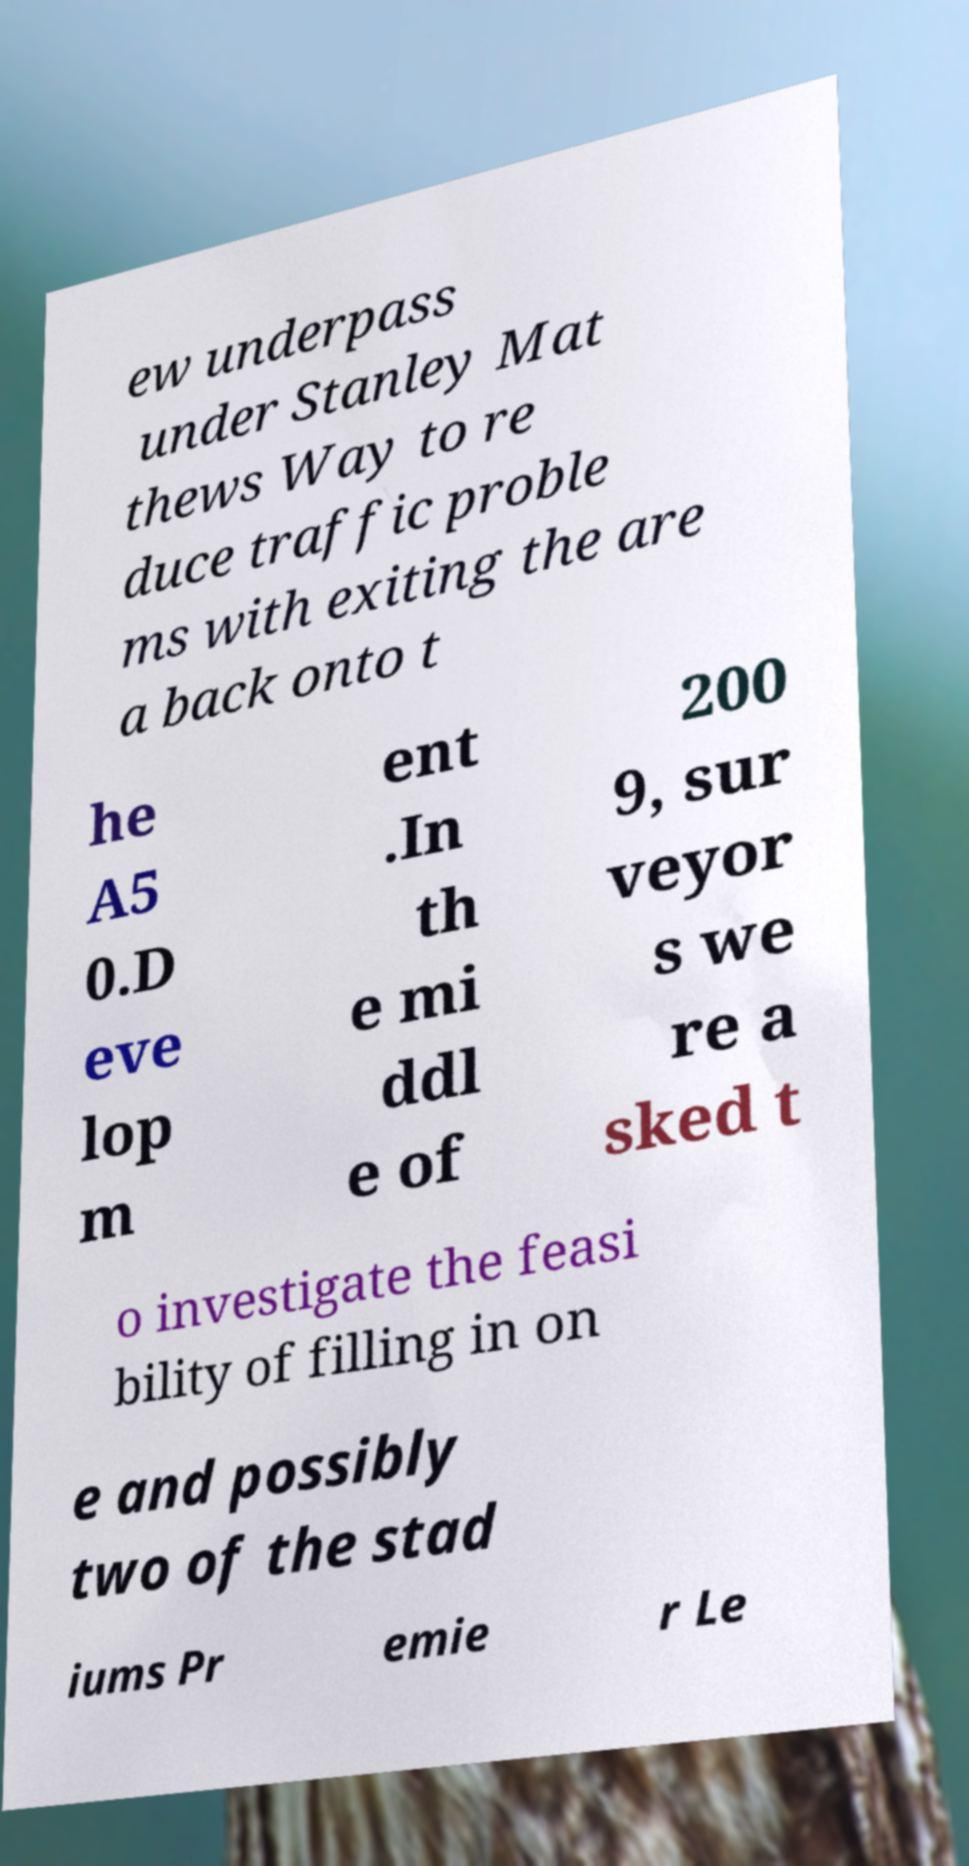Please identify and transcribe the text found in this image. ew underpass under Stanley Mat thews Way to re duce traffic proble ms with exiting the are a back onto t he A5 0.D eve lop m ent .In th e mi ddl e of 200 9, sur veyor s we re a sked t o investigate the feasi bility of filling in on e and possibly two of the stad iums Pr emie r Le 